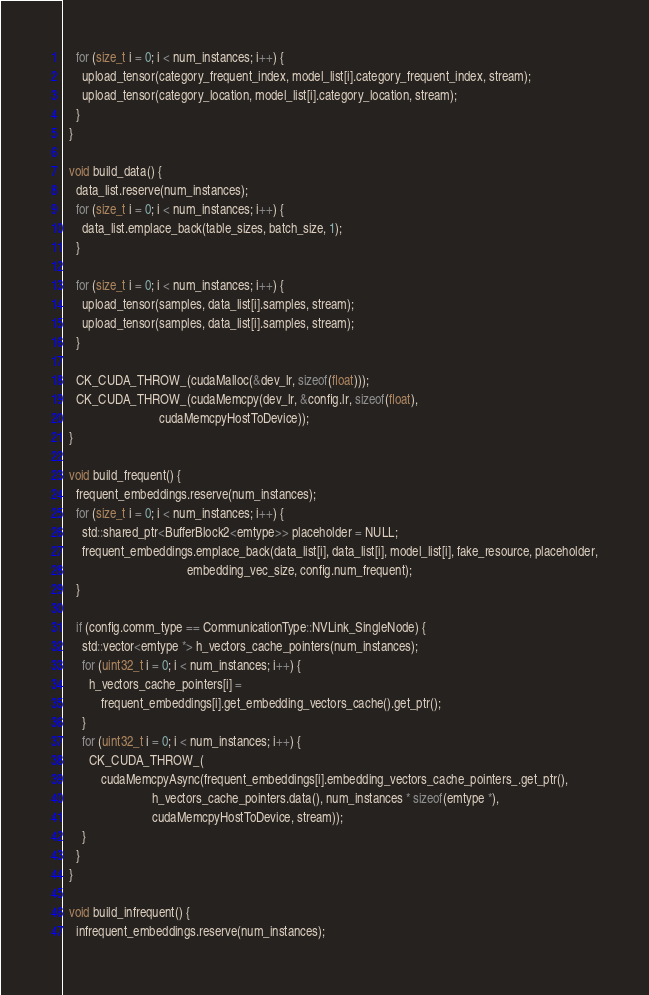Convert code to text. <code><loc_0><loc_0><loc_500><loc_500><_Cuda_>    for (size_t i = 0; i < num_instances; i++) {
      upload_tensor(category_frequent_index, model_list[i].category_frequent_index, stream);
      upload_tensor(category_location, model_list[i].category_location, stream);
    }
  }

  void build_data() {
    data_list.reserve(num_instances);
    for (size_t i = 0; i < num_instances; i++) {
      data_list.emplace_back(table_sizes, batch_size, 1);
    }

    for (size_t i = 0; i < num_instances; i++) {
      upload_tensor(samples, data_list[i].samples, stream);
      upload_tensor(samples, data_list[i].samples, stream);
    }

    CK_CUDA_THROW_(cudaMalloc(&dev_lr, sizeof(float)));
    CK_CUDA_THROW_(cudaMemcpy(dev_lr, &config.lr, sizeof(float),
                              cudaMemcpyHostToDevice));
  }

  void build_frequent() {
    frequent_embeddings.reserve(num_instances);
    for (size_t i = 0; i < num_instances; i++) {
      std::shared_ptr<BufferBlock2<emtype>> placeholder = NULL;
      frequent_embeddings.emplace_back(data_list[i], data_list[i], model_list[i], fake_resource, placeholder,
                                       embedding_vec_size, config.num_frequent);
    }

    if (config.comm_type == CommunicationType::NVLink_SingleNode) {
      std::vector<emtype *> h_vectors_cache_pointers(num_instances);
      for (uint32_t i = 0; i < num_instances; i++) {
        h_vectors_cache_pointers[i] =
            frequent_embeddings[i].get_embedding_vectors_cache().get_ptr();
      }
      for (uint32_t i = 0; i < num_instances; i++) {
        CK_CUDA_THROW_(
            cudaMemcpyAsync(frequent_embeddings[i].embedding_vectors_cache_pointers_.get_ptr(),
                            h_vectors_cache_pointers.data(), num_instances * sizeof(emtype *),
                            cudaMemcpyHostToDevice, stream));
      }
    }
  }

  void build_infrequent() {
    infrequent_embeddings.reserve(num_instances);</code> 